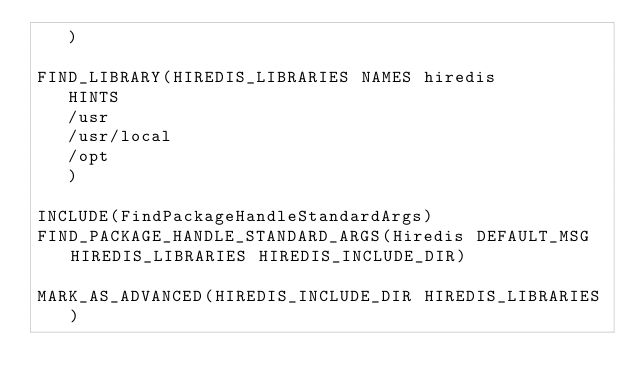<code> <loc_0><loc_0><loc_500><loc_500><_CMake_>   )

FIND_LIBRARY(HIREDIS_LIBRARIES NAMES hiredis
   HINTS
   /usr
   /usr/local
   /opt
   )

INCLUDE(FindPackageHandleStandardArgs)
FIND_PACKAGE_HANDLE_STANDARD_ARGS(Hiredis DEFAULT_MSG HIREDIS_LIBRARIES HIREDIS_INCLUDE_DIR)

MARK_AS_ADVANCED(HIREDIS_INCLUDE_DIR HIREDIS_LIBRARIES)
</code> 